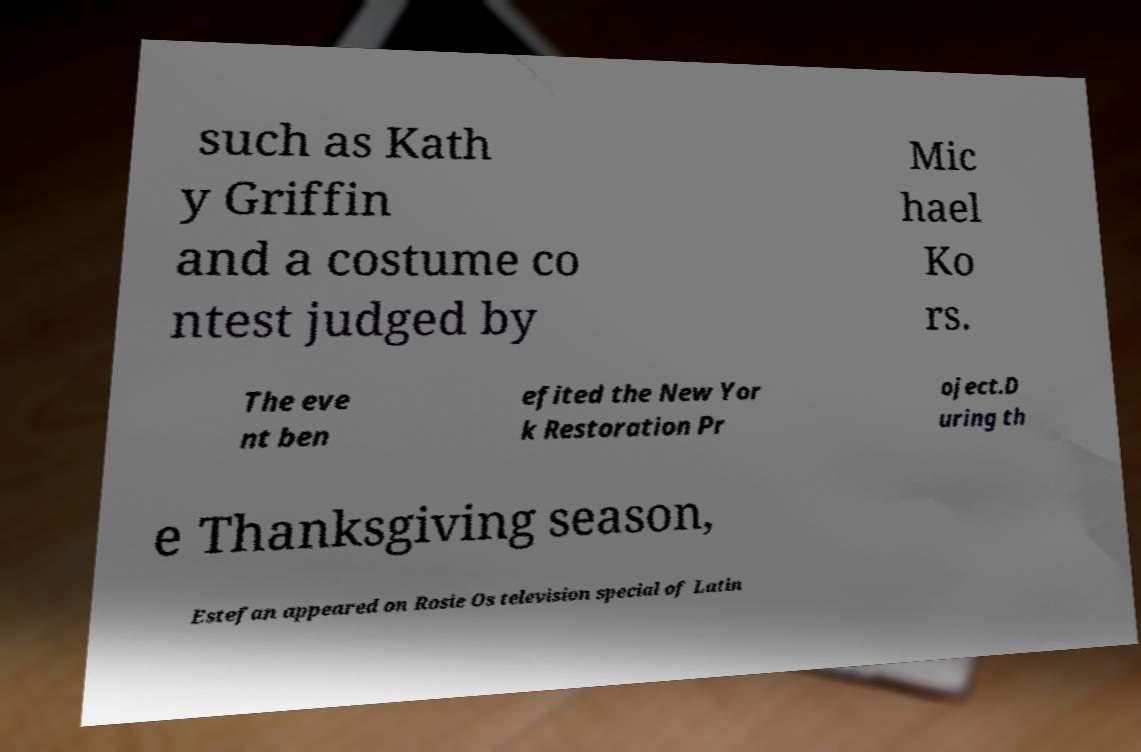For documentation purposes, I need the text within this image transcribed. Could you provide that? such as Kath y Griffin and a costume co ntest judged by Mic hael Ko rs. The eve nt ben efited the New Yor k Restoration Pr oject.D uring th e Thanksgiving season, Estefan appeared on Rosie Os television special of Latin 